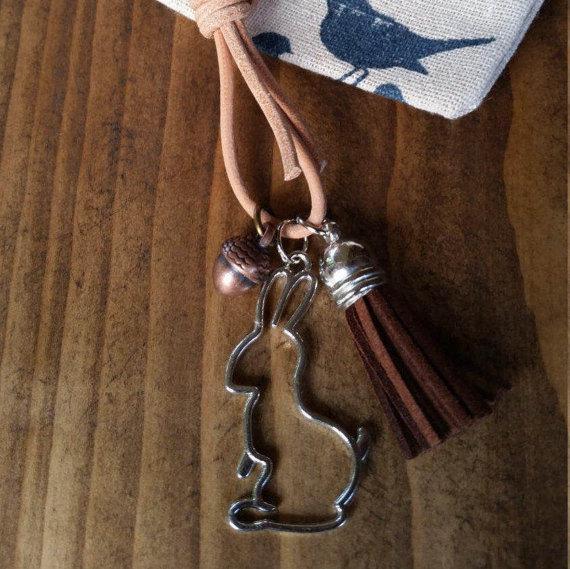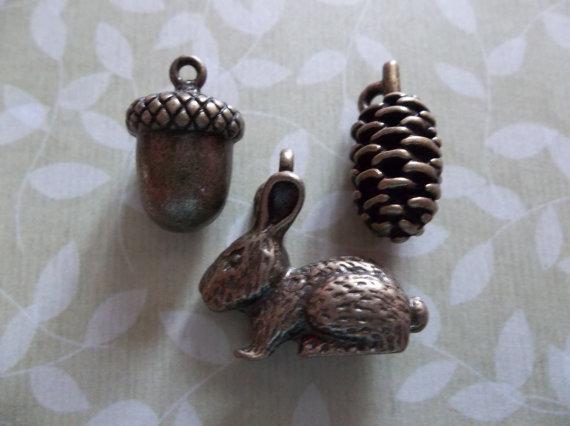The first image is the image on the left, the second image is the image on the right. For the images shown, is this caption "At least one object is made of wood." true? Answer yes or no. No. The first image is the image on the left, the second image is the image on the right. Given the left and right images, does the statement "An image includes charms shaped like a rabbit, an acorn and a pinecone, displayed on a surface decorated with a foliage pattern." hold true? Answer yes or no. Yes. 